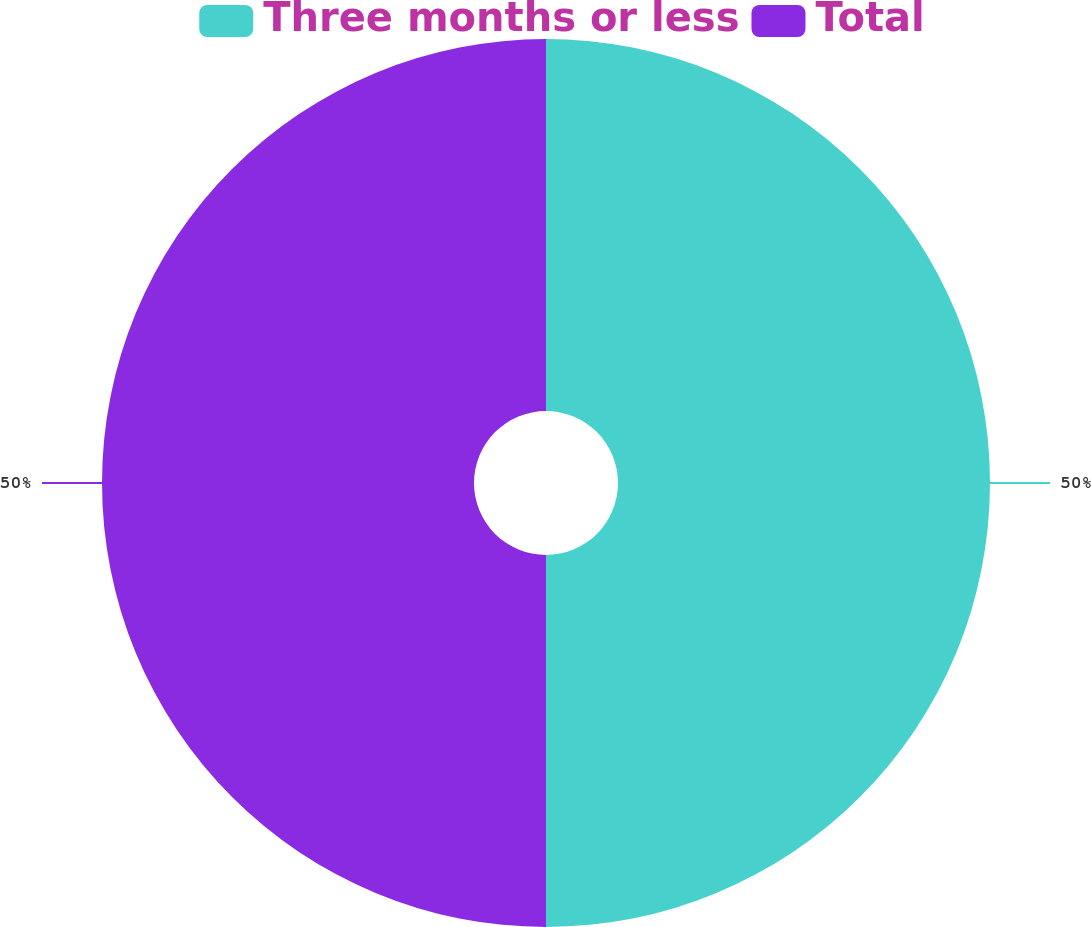Convert chart. <chart><loc_0><loc_0><loc_500><loc_500><pie_chart><fcel>Three months or less<fcel>Total<nl><fcel>50.0%<fcel>50.0%<nl></chart> 